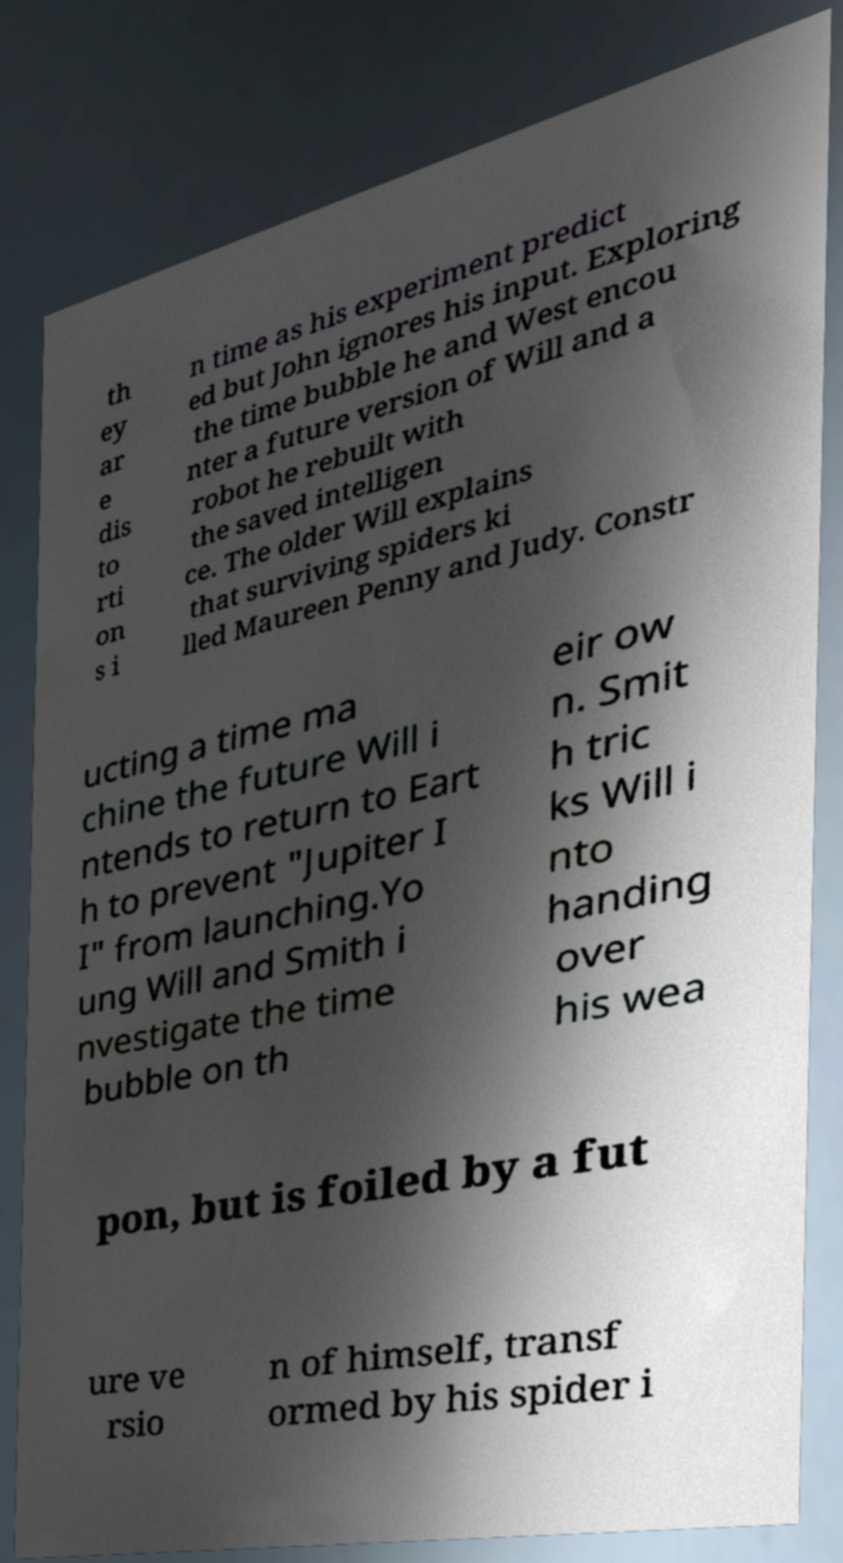Please read and relay the text visible in this image. What does it say? th ey ar e dis to rti on s i n time as his experiment predict ed but John ignores his input. Exploring the time bubble he and West encou nter a future version of Will and a robot he rebuilt with the saved intelligen ce. The older Will explains that surviving spiders ki lled Maureen Penny and Judy. Constr ucting a time ma chine the future Will i ntends to return to Eart h to prevent "Jupiter I I" from launching.Yo ung Will and Smith i nvestigate the time bubble on th eir ow n. Smit h tric ks Will i nto handing over his wea pon, but is foiled by a fut ure ve rsio n of himself, transf ormed by his spider i 